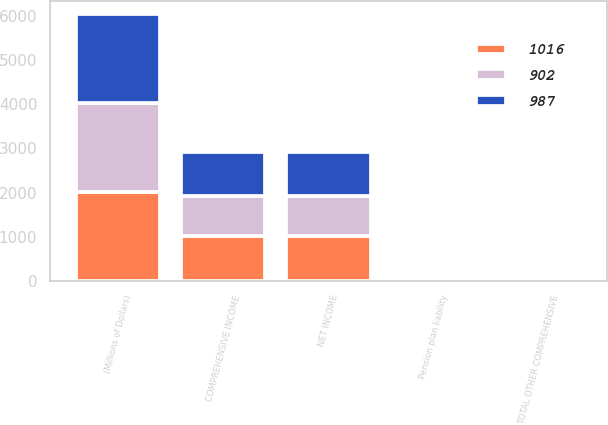<chart> <loc_0><loc_0><loc_500><loc_500><stacked_bar_chart><ecel><fcel>(Millions of Dollars)<fcel>NET INCOME<fcel>Pension plan liability<fcel>TOTAL OTHER COMPREHENSIVE<fcel>COMPREHENSIVE INCOME<nl><fcel>1016<fcel>2012<fcel>1017<fcel>1<fcel>1<fcel>1016<nl><fcel>987<fcel>2011<fcel>989<fcel>2<fcel>2<fcel>987<nl><fcel>902<fcel>2010<fcel>904<fcel>2<fcel>2<fcel>902<nl></chart> 